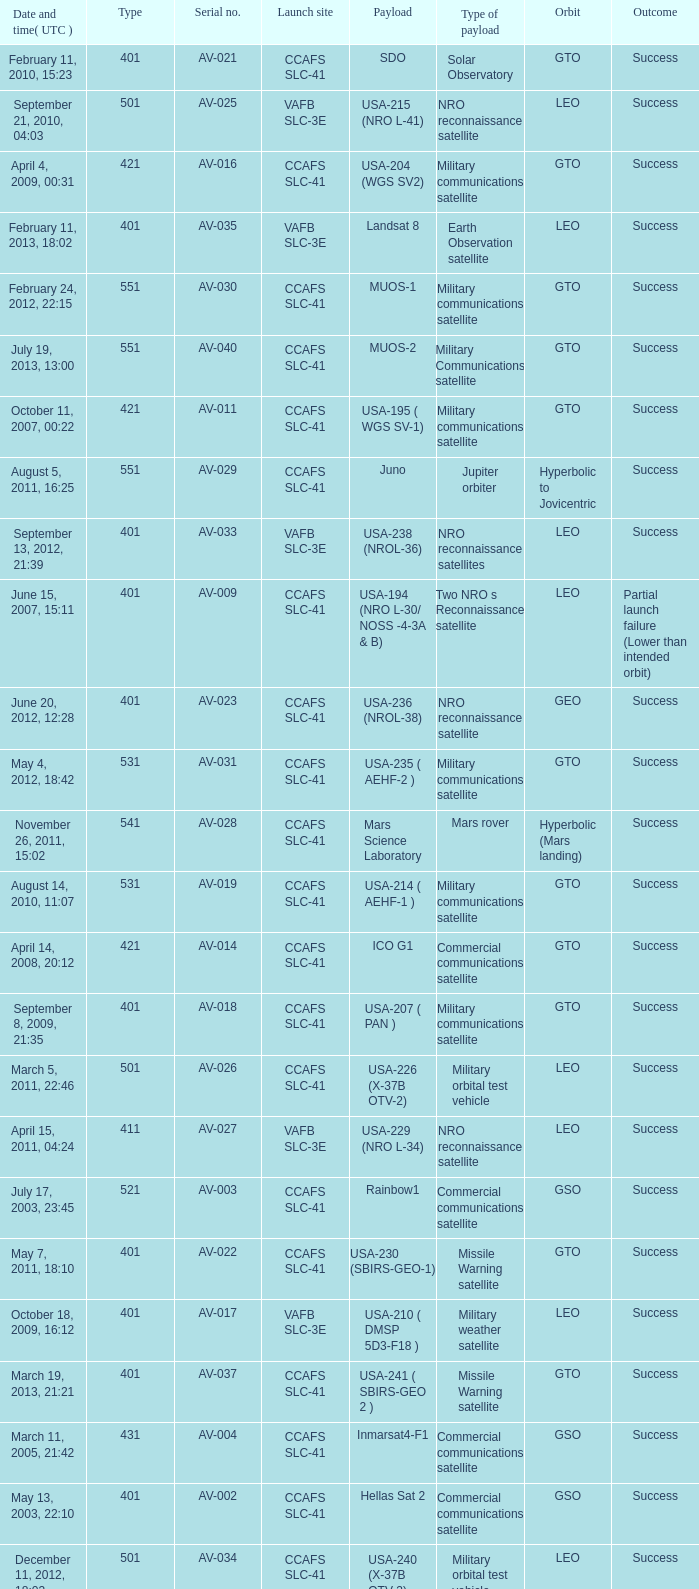When was the payload of Commercial Communications Satellite amc16? December 17, 2004, 12:07. 